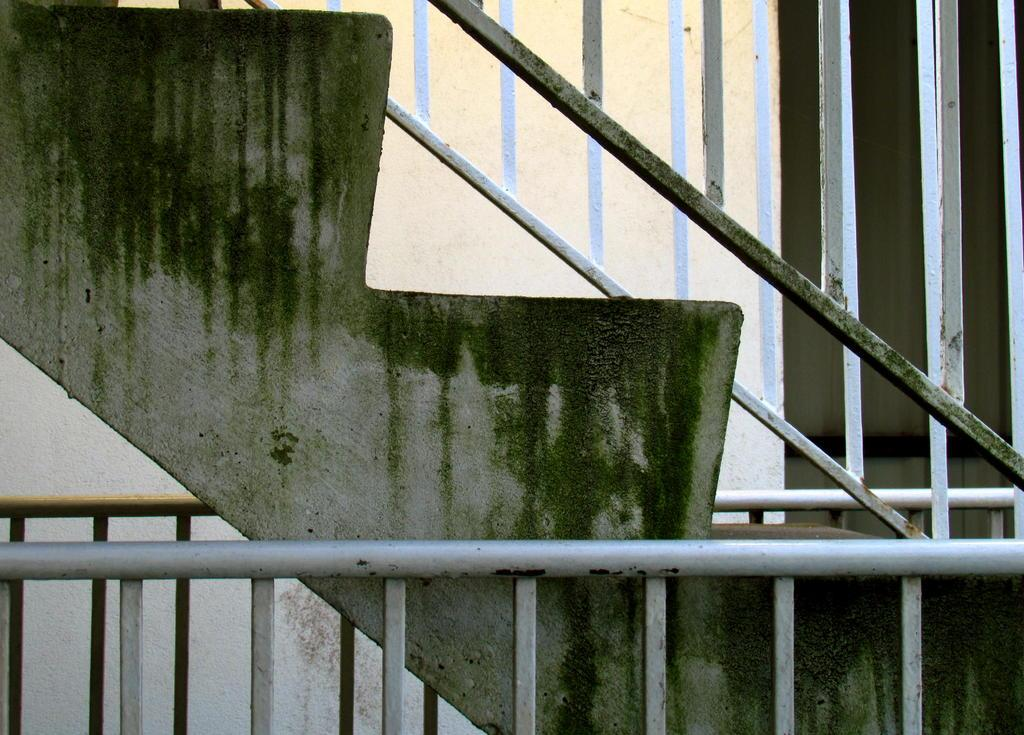What type of structure is present in the image? There are stairs in the image. What is covering the stairs? There is algae on the stairs. Is there any additional feature associated with the stairs? Yes, there is a railing associated with the stairs. What type of curtain can be seen hanging from the boundary in the image? There is no curtain or boundary present in the image; it features stairs with algae and a railing. 